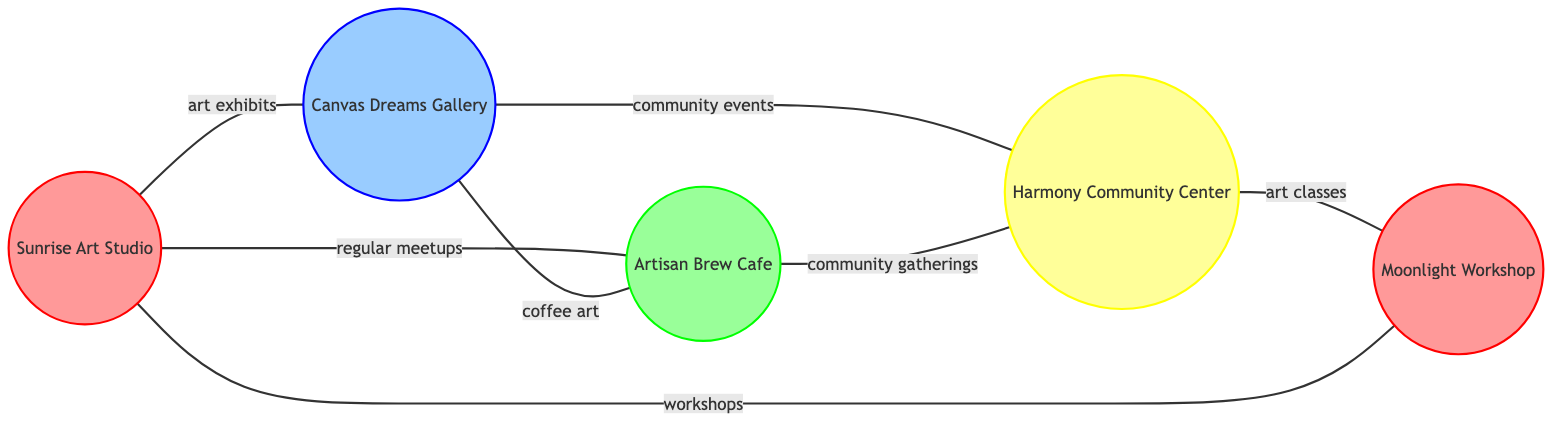What is the total number of art spaces represented in the diagram? The diagram lists five nodes, which represent different art spaces: Sunrise Art Studio, Canvas Dreams Gallery, Artisan Brew Cafe, Harmony Community Center, and Moonlight Workshop. Therefore, counting these gives a total of five.
Answer: 5 Which art space is directly connected to both Sunrise Art Studio and Artisan Brew Cafe? From the connections in the diagram, Sunrise Art Studio is connected to Canvas Dreams Gallery and Artisan Brew Cafe, while Artisan Brew Cafe is also connected to Canvas Dreams Gallery. This indicates that the only art space directly connected to both is Canvas Dreams Gallery.
Answer: Canvas Dreams Gallery What type of relationship exists between Moonlight Workshop and Sunrise Art Studio? The diagram indicates a connection labeled "workshops" between Moonlight Workshop and Sunrise Art Studio. This suggests that they collaborate or share workshops.
Answer: workshops How many community events are hosted between galleries and community centers? The diagram shows that there are two connections between galleries and community centers: one between Canvas Dreams Gallery and Harmony Community Center labeled "community events" and another connection from Harmony Community Center to Moonlight Workshop, which is not directly a gallery but is a studio. Thus, the specific count of community events based solely on gallery to community center connections is one.
Answer: 1 Which studio has a direct relationship with Harmony Community Center? The diagram shows a direct connection between both Harmony Community Center and Moonlight Workshop, indicating that these two share a relationship labeled "art classes." Therefore, the studio that has a direct relationship with Harmony Community Center is Moonlight Workshop.
Answer: Moonlight Workshop In total, how many edges are present in the diagram? By counting the edges listed, there are seven connections: one between Sunrise Art Studio and Canvas Dreams Gallery, one between Sunrise Art Studio and Artisan Brew Cafe, and so on. Adding these gives a total of seven edges in the diagram.
Answer: 7 What type of venue is Artisan Brew Cafe categorized as in the diagram? The diagram identifies Artisan Brew Cafe with a label and a specific color that indicates its type as a cafe.
Answer: cafe 